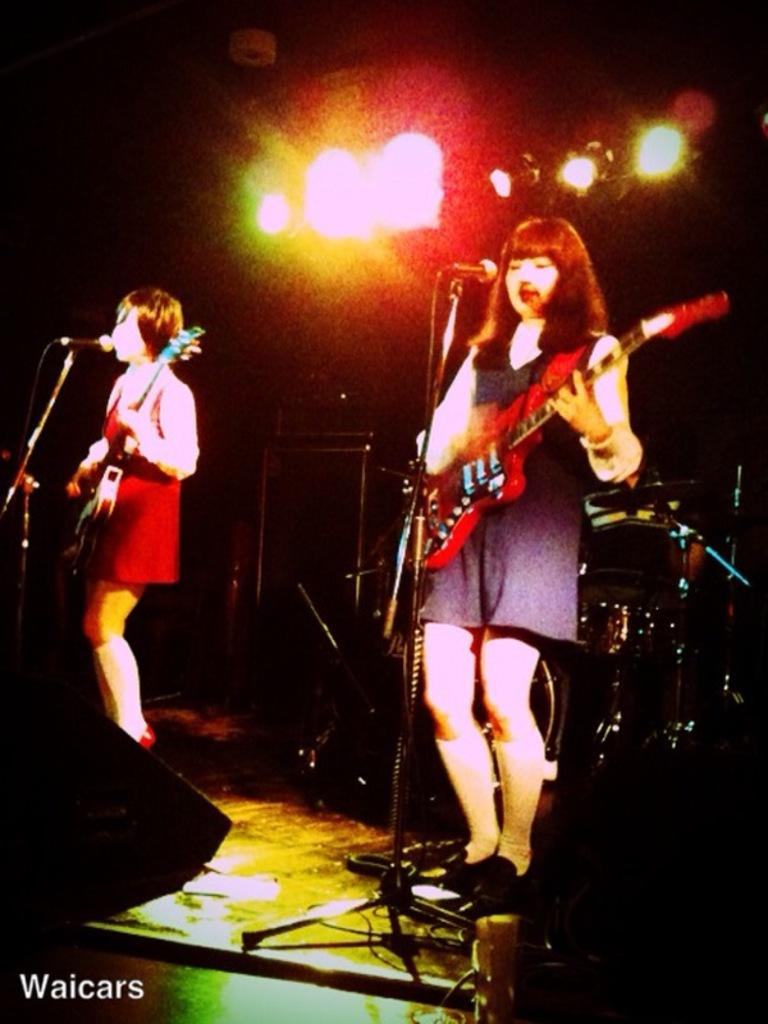How many women are in the image? There are two women in the image. What are the women doing in the image? The women are standing and holding guitars in their hands. What objects are in front of the women? There are microphones in front of the women. What can be seen in the background of the image? There are lights visible in the background. What type of liquid is being poured into the guitar in the image? There is no liquid being poured into the guitar in the image; the women are simply holding guitars. What design elements can be seen on the microphones in the image? The provided facts do not mention any specific design elements on the microphones, so we cannot answer this question definitively. 